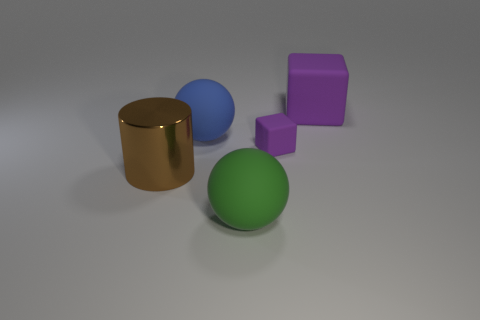Are there any shiny things of the same size as the green matte thing?
Your answer should be compact. Yes. What is the material of the object on the left side of the large blue rubber sphere?
Your response must be concise. Metal. The large block that is the same material as the tiny purple block is what color?
Provide a short and direct response. Purple. What number of rubber things are either big gray spheres or large blue things?
Your answer should be very brief. 1. The purple rubber thing that is the same size as the green object is what shape?
Offer a very short reply. Cube. What number of things are cubes in front of the blue thing or large rubber things behind the cylinder?
Offer a terse response. 3. What is the material of the brown cylinder that is the same size as the green ball?
Make the answer very short. Metal. What number of other objects are the same material as the large blue object?
Your answer should be very brief. 3. Is the number of large blue matte objects behind the blue object the same as the number of cylinders that are to the left of the big block?
Provide a short and direct response. No. How many purple objects are big matte blocks or tiny matte blocks?
Your response must be concise. 2. 